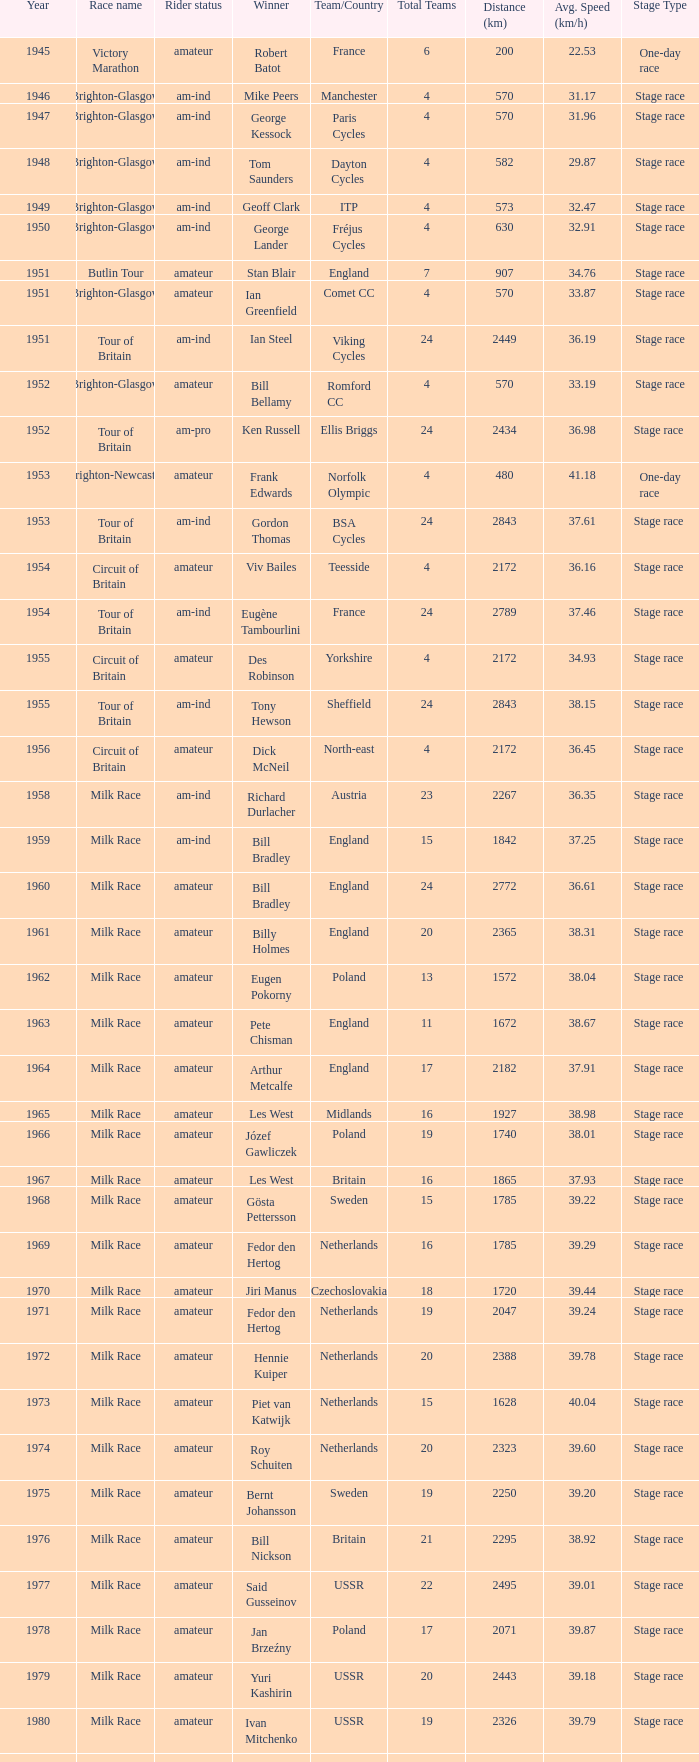What is the rider status for the 1971 netherlands team? Amateur. 